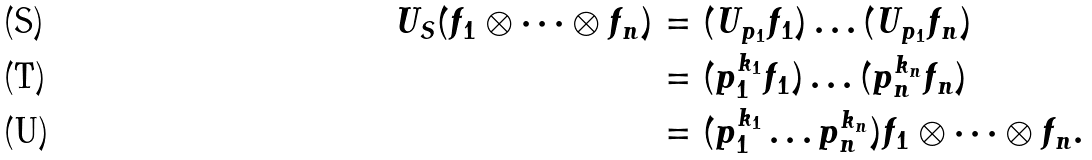<formula> <loc_0><loc_0><loc_500><loc_500>\ U _ { S } ( f _ { 1 } \otimes \cdots \otimes f _ { n } ) & = ( U _ { p _ { 1 } } f _ { 1 } ) \dots ( U _ { p _ { 1 } } f _ { n } ) \\ & = ( p _ { 1 } ^ { k _ { 1 } } f _ { 1 } ) \dots ( p _ { n } ^ { k _ { n } } f _ { n } ) \\ & = ( p _ { 1 } ^ { k _ { 1 } } \dots p _ { n } ^ { k _ { n } } ) f _ { 1 } \otimes \cdots \otimes f _ { n } .</formula> 